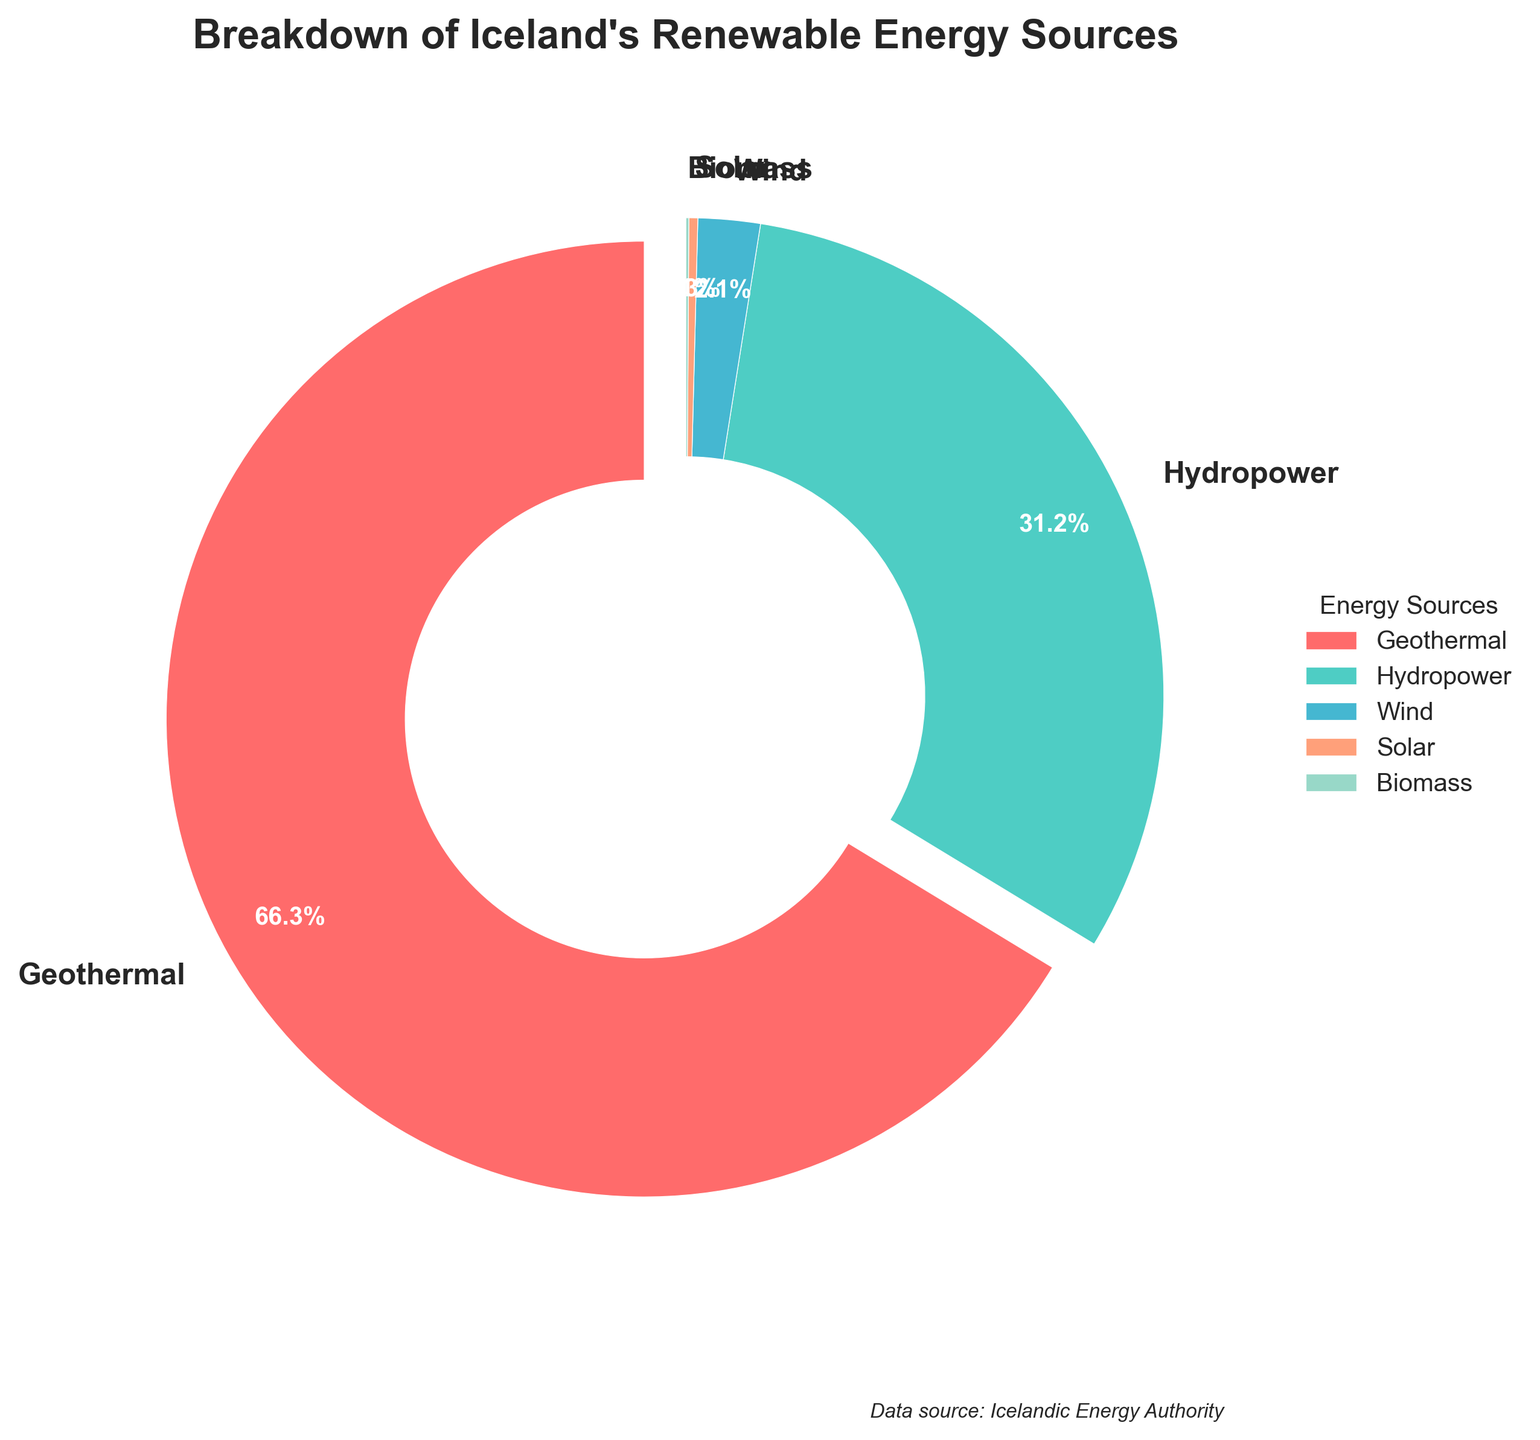what is the largest segment in the pie chart? The largest segment in the pie chart is labeled "Geothermal" which occupies 66.3% of the pie
Answer: Geothermal What is the combined percentage of Hydropower and Wind energy sources? To find the combined percentage, add the percentages of Hydropower (31.2%) and Wind (2.1%): 31.2 + 2.1 = 33.3%
Answer: 33.3% Which energy sources together make up more than half of the renewable energy? The energy sources "Geothermal" (66.3%) alone make up more than half of the renewable energy sources
Answer: Geothermal Which is greater, the percentage of Solar energy or Biomass energy? By comparing the percentages, Solar energy has 0.3% and Biomass energy has 0.1%, so Solar energy is greater
Answer: Solar How does the percentage of Hydropower compare to that of Geothermal? The percentage of Hydropower (31.2%) is much less than that of Geothermal (66.3%)
Answer: Less than Which segment has the smallest percentage and what is it? The smallest segment in the pie chart is labeled "Biomass" which occupies 0.1% of the pie
Answer: Biomass, 0.1% What is the total percentage of energy sources other than Geothermal? To find the total percentage other than Geothermal, add Hydropower (31.2%), Wind (2.1%), Solar (0.3%), and Biomass (0.1%): 31.2 + 2.1 + 0.3 + 0.1 = 33.7%
Answer: 33.7% What is the visual indication that Geothermal is the largest energy source on the pie chart? The visual indication is that the segment representing "Geothermal" is both exploded (separated slightly) from the pie and occupies the largest area compared to other segments
Answer: Exploded, Largest area How much smaller is the percentage of Wind energy compared to Hydropower? To find this, subtract the percentage of Wind (2.1%) from Hydropower (31.2%): 31.2 - 2.1 = 29.1%
Answer: 29.1% Which segments are represented by shades of blue and what are their respective percentages? The segments represented by shades of blue are "Hydropower" with 31.2% and "Wind" with 2.1%
Answer: Hydropower 31.2%, Wind 2.1% 